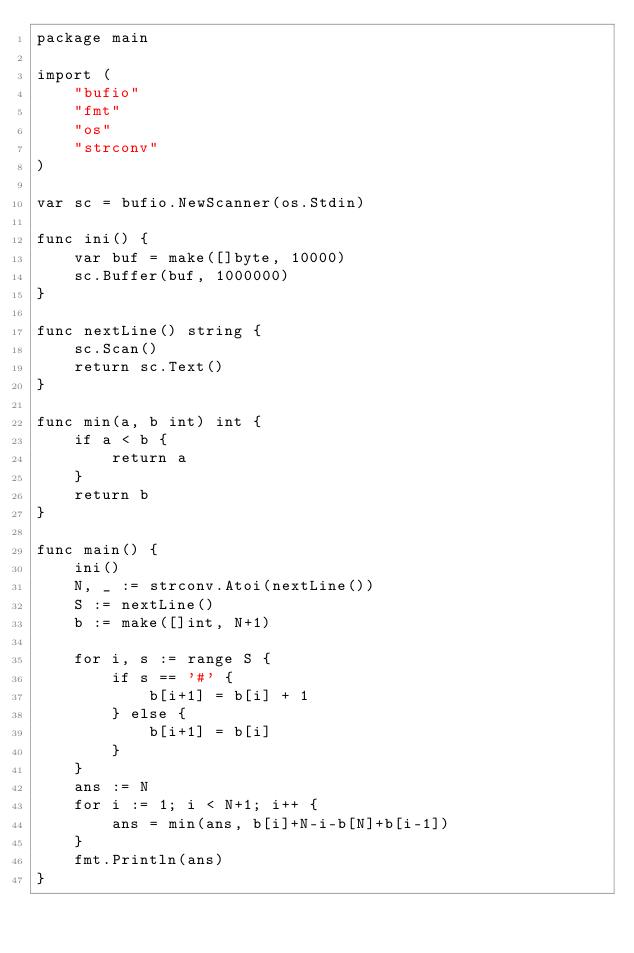Convert code to text. <code><loc_0><loc_0><loc_500><loc_500><_Go_>package main

import (
	"bufio"
	"fmt"
	"os"
	"strconv"
)

var sc = bufio.NewScanner(os.Stdin)

func ini() {
	var buf = make([]byte, 10000)
	sc.Buffer(buf, 1000000)
}

func nextLine() string {
	sc.Scan()
	return sc.Text()
}

func min(a, b int) int {
	if a < b {
		return a
	}
	return b
}

func main() {
	ini()
	N, _ := strconv.Atoi(nextLine())
	S := nextLine()
	b := make([]int, N+1)

	for i, s := range S {
		if s == '#' {
			b[i+1] = b[i] + 1
		} else {
			b[i+1] = b[i]
		}
	}
	ans := N
	for i := 1; i < N+1; i++ {
		ans = min(ans, b[i]+N-i-b[N]+b[i-1])
	}
	fmt.Println(ans)
}
</code> 